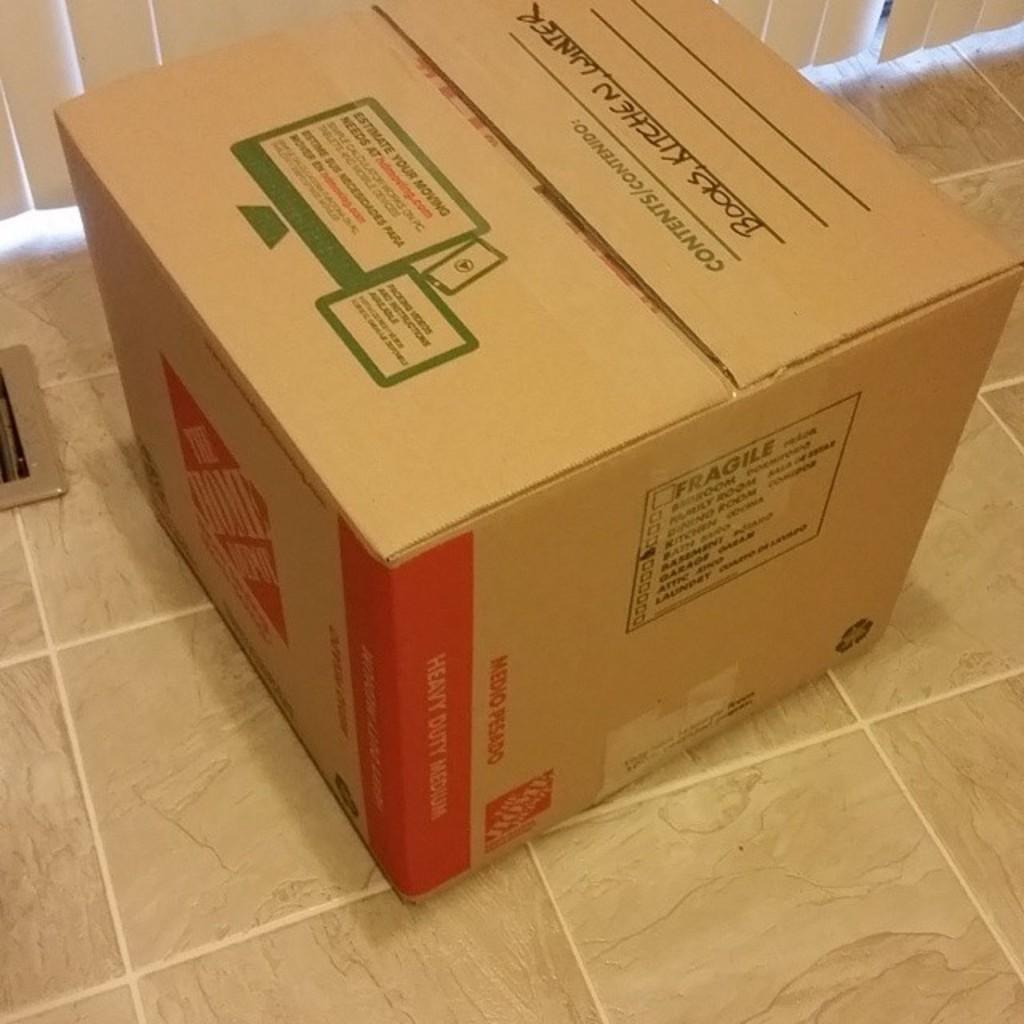<image>
Render a clear and concise summary of the photo. a box on the ground that is labeled 'books, kitchen, winter' on it 